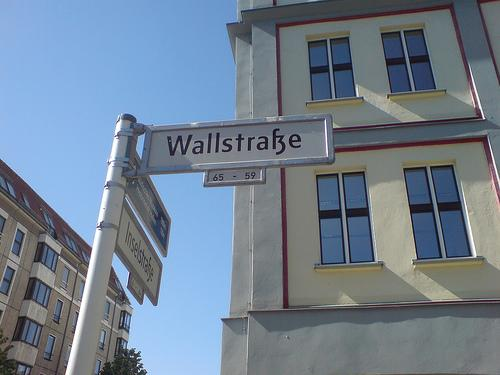Describe the aesthetic appearance of the buildings in the image. The buildings are white and yellow, with red trim around windows and red paint in the window frames. Talk about the sky in the image. The sky is a clear, bright blue above the buildings. What's happening in the image's background? City street corner scene with white and yellow buildings, clear blue sky, and red trimmed windows. Enumerate the signs on the sign post in the image. White street sign, blue sign, white sign with writing, and black numbers. Give a quick summary of what the photo presents. A city street corner with a white street sign, buildings, and a clear blue sky above. Describe the additional signs on the post in the image. There are white and blue signs on the post, one with white writing and black numbers. Mention the features seen in the street sign. The street sign is white with black writing, silver border, and says "Wallstrafze 6569". Provide a brief description of the most prominent object in the image. A white rectangular street sign on a pole with black writing and a silver border, stating "Wallstrafze 6569". Mention the position of the street sign in the image. The street sign is on a post in the left-center of the image. State the purpose of the street sign in the image. The street sign indicates the location, Wallstrafze 6569. 